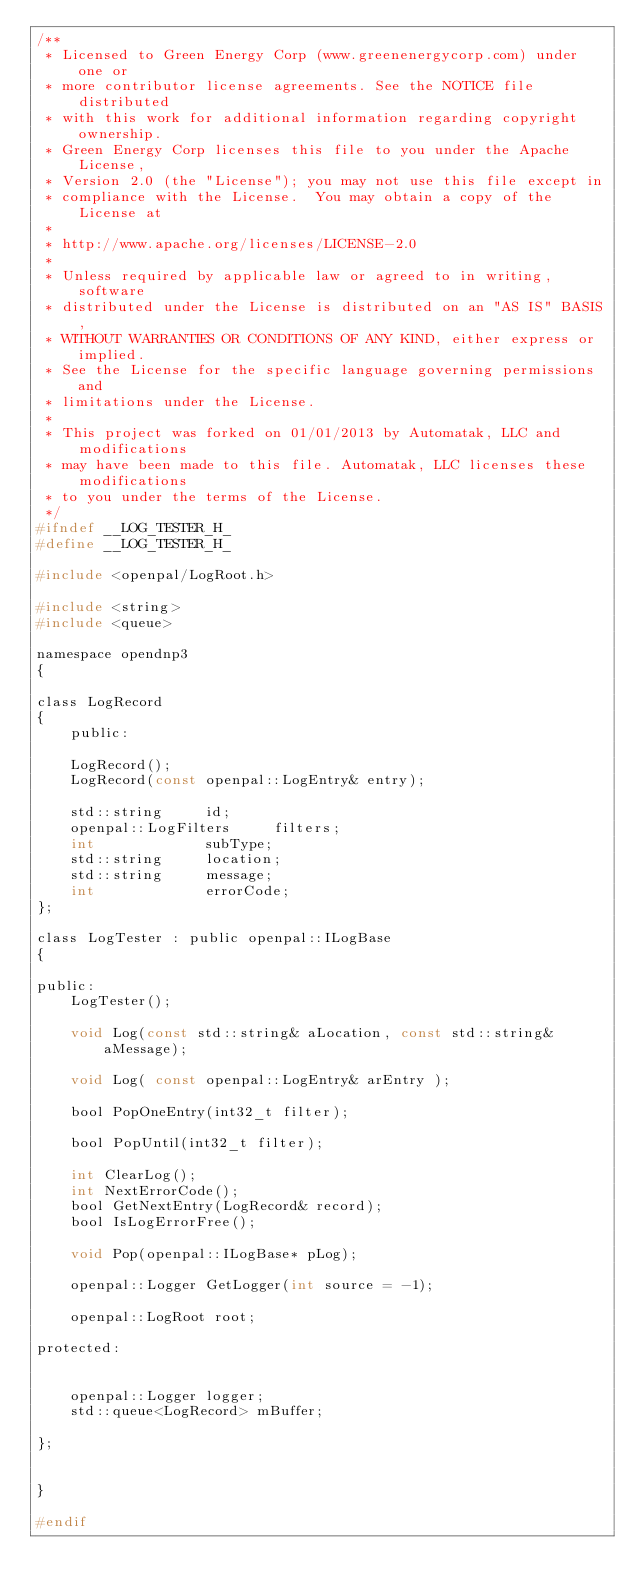<code> <loc_0><loc_0><loc_500><loc_500><_C_>/**
 * Licensed to Green Energy Corp (www.greenenergycorp.com) under one or
 * more contributor license agreements. See the NOTICE file distributed
 * with this work for additional information regarding copyright ownership.
 * Green Energy Corp licenses this file to you under the Apache License,
 * Version 2.0 (the "License"); you may not use this file except in
 * compliance with the License.  You may obtain a copy of the License at
 *
 * http://www.apache.org/licenses/LICENSE-2.0
 *
 * Unless required by applicable law or agreed to in writing, software
 * distributed under the License is distributed on an "AS IS" BASIS,
 * WITHOUT WARRANTIES OR CONDITIONS OF ANY KIND, either express or implied.
 * See the License for the specific language governing permissions and
 * limitations under the License.
 *
 * This project was forked on 01/01/2013 by Automatak, LLC and modifications
 * may have been made to this file. Automatak, LLC licenses these modifications
 * to you under the terms of the License.
 */
#ifndef __LOG_TESTER_H_
#define __LOG_TESTER_H_

#include <openpal/LogRoot.h>

#include <string>
#include <queue>

namespace opendnp3
{

class LogRecord
{
	public:

	LogRecord();
	LogRecord(const openpal::LogEntry& entry);

	std::string		id;
	openpal::LogFilters		filters;
	int				subType;
	std::string		location;
	std::string		message;
	int				errorCode;
};

class LogTester : public openpal::ILogBase
{

public:
	LogTester();

	void Log(const std::string& aLocation, const std::string& aMessage);

	void Log( const openpal::LogEntry& arEntry );

	bool PopOneEntry(int32_t filter);

	bool PopUntil(int32_t filter);

	int ClearLog();
	int NextErrorCode();
	bool GetNextEntry(LogRecord& record);
	bool IsLogErrorFree();

	void Pop(openpal::ILogBase* pLog);

	openpal::Logger GetLogger(int source = -1);

	openpal::LogRoot root;

protected:

	
	openpal::Logger logger;
	std::queue<LogRecord> mBuffer;

};


}

#endif
</code> 